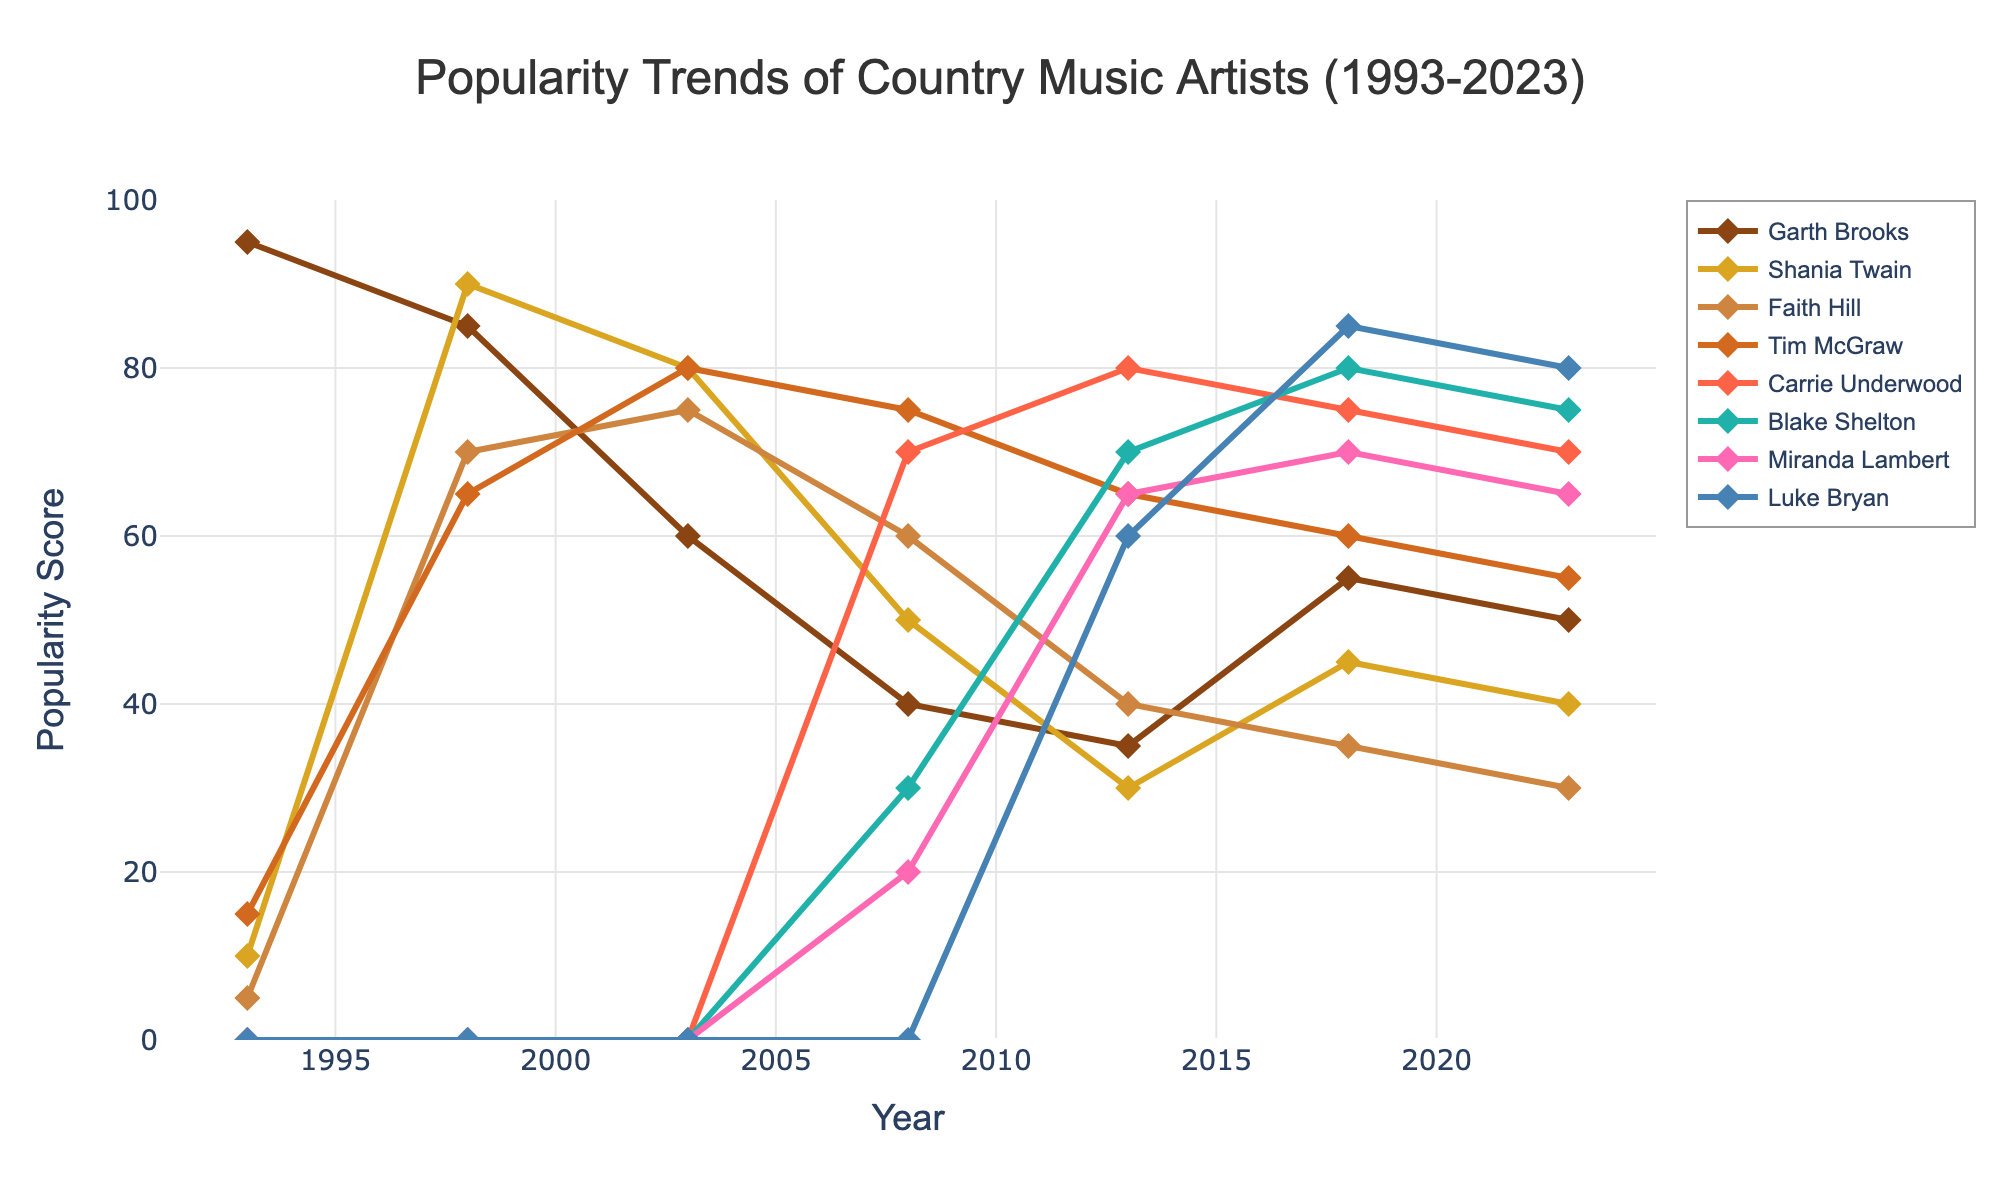what is the popularity score of Garth Brooks in 1998? Look at the line representing Garth Brooks in 1998 on the x-axis and read the corresponding y-axis value.
Answer: 85 Which artist has the highest popularity score in 2023? Compare the y-axis values for all artists in 2023.
Answer: Luke Bryan How did Faith Hill's popularity change from 2003 to 2013? Locate Faith Hill's line at 2003 and 2013 on the x-axis and observe the change in y-axis values.
Answer: It decreased from 75 to 40 What is the average popularity score of Carrie Underwood between 2008 and 2023? Note the y-axis values for Carrie Underwood in the years 2008 (70), 2013 (80), 2018 (75), and 2023 (70). Calculate the average: (70+80+75+70)/4.
Answer: 73.75 What year did Blake Shelton first appear, and what was his score? Find the first year Blake Shelton has a non-zero y-axis value.
Answer: 2008, 30 Compare the popularity trend of Shania Twain and Miranda Lambert from 2013 to 2018. Observe the lines for Shania Twain and Miranda Lambert and compare the changes in y-axis values between 2013 and 2018.
Answer: Shania Twain's popularity increased slightly while Miranda Lambert's popularity increased significantly Did Tim McGraw's popularity peak before or after 2010? Observe Tim McGraw's line and identify his highest y-axis value relative to the 2010 mark on the x-axis.
Answer: After 2010 Which artist had the most significant drop in popularity between 1993 and 1998? Compare the differences in y-axis values for all artists from 1993 to 1998.
Answer: Garth Brooks Who had a higher popularity score in 2008, Faith Hill or Tim McGraw? Compare the y-axis values of Faith Hill and Tim McGraw in 2008.
Answer: Tim McGraw What is the sum of Luke Bryan's popularity scores for 2013 and 2018? Note the y-axis values for Luke Bryan in 2013 (60) and 2018 (85) and add them together: 60 + 85.
Answer: 145 